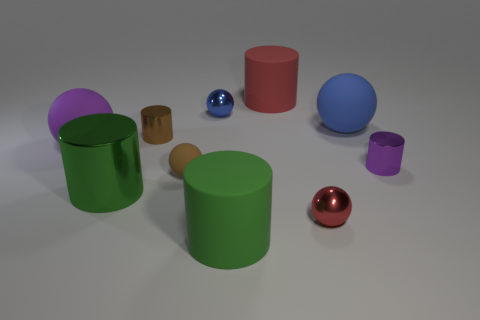How many large matte cylinders are in front of the purple metal cylinder and behind the tiny red metal object?
Offer a very short reply. 0. What material is the brown cylinder?
Ensure brevity in your answer.  Metal. How many things are green rubber cylinders or red matte objects?
Keep it short and to the point. 2. Is the size of the shiny ball on the right side of the big red matte cylinder the same as the blue sphere that is on the right side of the big red cylinder?
Keep it short and to the point. No. What number of other things are there of the same size as the green metal cylinder?
Your answer should be very brief. 4. How many objects are rubber things left of the red rubber cylinder or big spheres to the left of the large red matte thing?
Keep it short and to the point. 3. Is the large red cylinder made of the same material as the blue thing on the left side of the big red rubber cylinder?
Provide a succinct answer. No. How many other objects are the same shape as the blue rubber object?
Provide a short and direct response. 4. What material is the red thing behind the metallic thing to the right of the red object in front of the tiny blue metal ball made of?
Your answer should be compact. Rubber. Are there an equal number of tiny objects that are behind the small purple shiny cylinder and small cylinders?
Offer a terse response. Yes. 